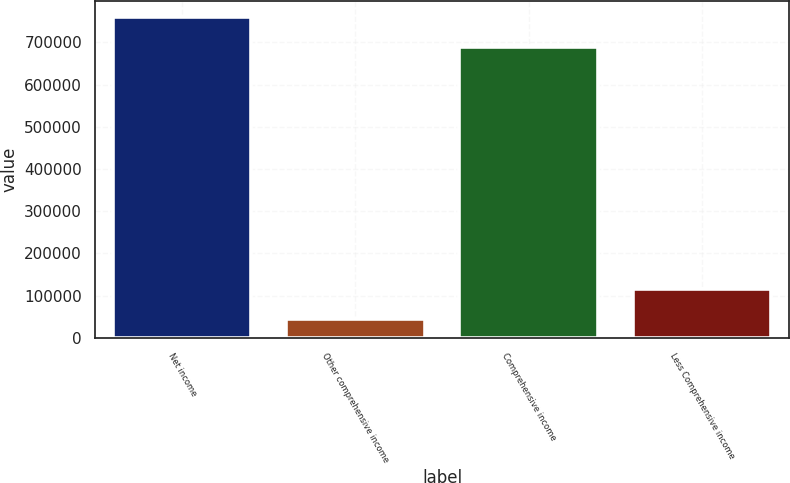<chart> <loc_0><loc_0><loc_500><loc_500><bar_chart><fcel>Net income<fcel>Other comprehensive income<fcel>Comprehensive income<fcel>Less Comprehensive income<nl><fcel>760495<fcel>45004<fcel>689692<fcel>115807<nl></chart> 